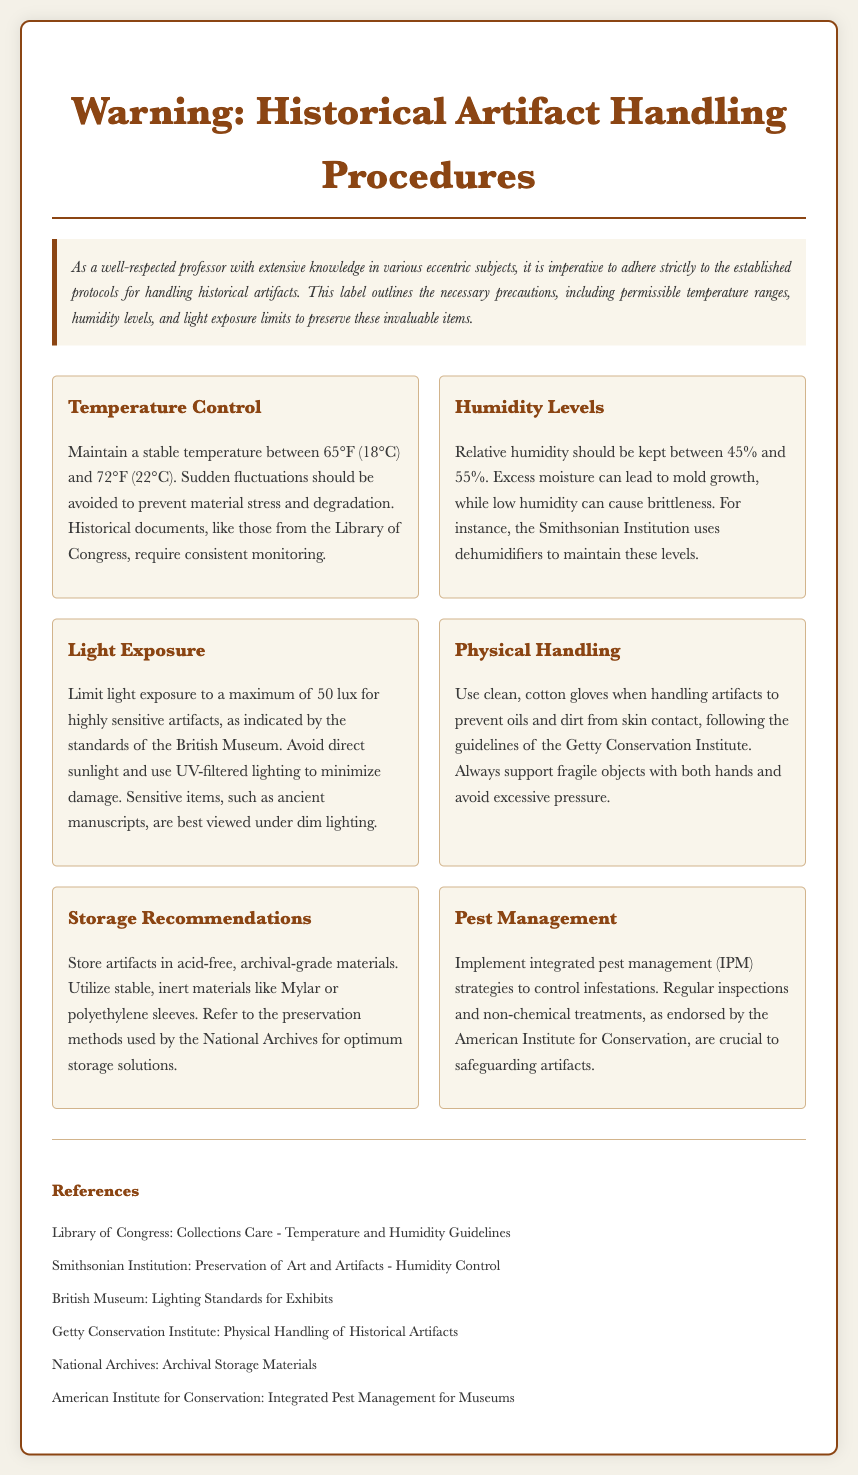What is the permissible temperature range for historical artifacts? The document specifies that the stable temperature should be maintained between 65°F (18°C) and 72°F (22°C).
Answer: 65°F (18°C) and 72°F (22°C) What is the recommended relative humidity range? The document indicates that relative humidity should be kept between 45% and 55%.
Answer: 45% and 55% What is the maximum light exposure in lux for highly sensitive artifacts? According to the document, light exposure should be limited to a maximum of 50 lux for highly sensitive artifacts.
Answer: 50 lux What type of gloves should be used when handling artifacts? The document states to use clean, cotton gloves when handling artifacts.
Answer: clean, cotton gloves Which institution emphasizes the use of dehumidifiers to maintain humidity levels? The document mentions that the Smithsonian Institution uses dehumidifiers to maintain these levels.
Answer: Smithsonian Institution What are the storage materials recommended for artifacts? The label recommends storing artifacts in acid-free, archival-grade materials.
Answer: acid-free, archival-grade materials What strategy is recommended for pest management in artifact handling? The document endorses implementing integrated pest management (IPM) strategies for pest control.
Answer: integrated pest management (IPM) What should be avoided to prevent damage during handling? The document advises to avoid excessive pressure while handling artifacts.
Answer: excessive pressure 